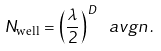Convert formula to latex. <formula><loc_0><loc_0><loc_500><loc_500>N _ { \text {well} } = \left ( \frac { \lambda } { 2 } \right ) ^ { \, D } \ a v g n \, .</formula> 